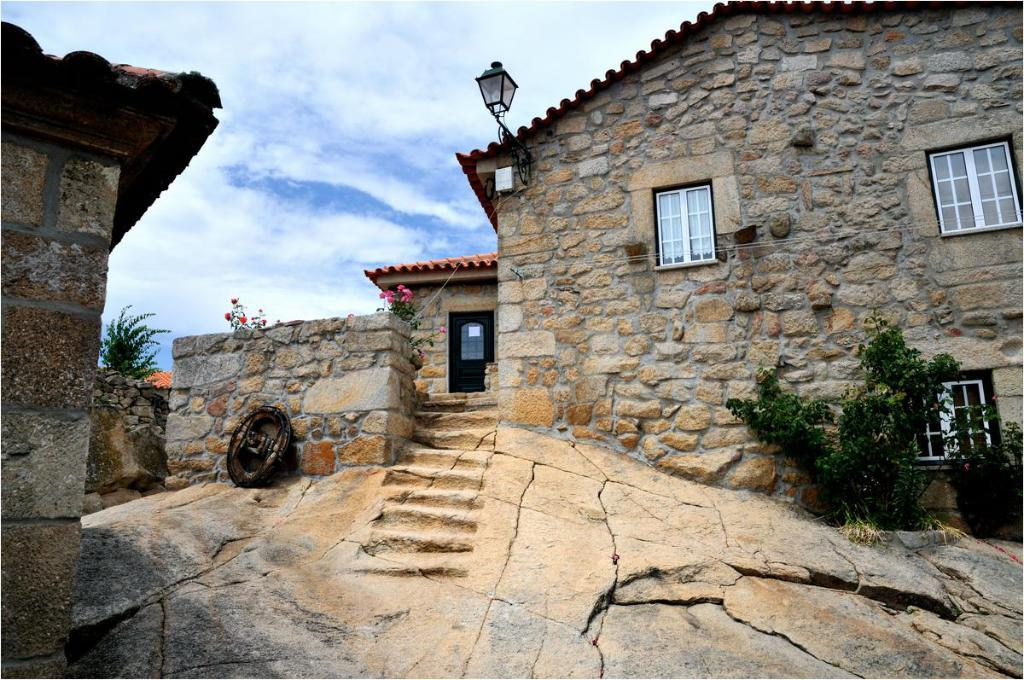What type of structure is present in the image? There is a building in the picture. What architectural feature can be seen in the image? There are stairs in the picture. What type of vegetation is visible in the image? There are plants and trees in the picture. What is the condition of the sky in the image? The sky is clear in the picture. What type of peace can be seen in the alley in the image? There is no alley or peace present in the image; it features a building, stairs, plants, trees, and a clear sky. What type of loaf is being baked in the building in the image? There is no indication of any baking or loaves in the image; it only shows a building, stairs, plants, trees, and a clear sky. 